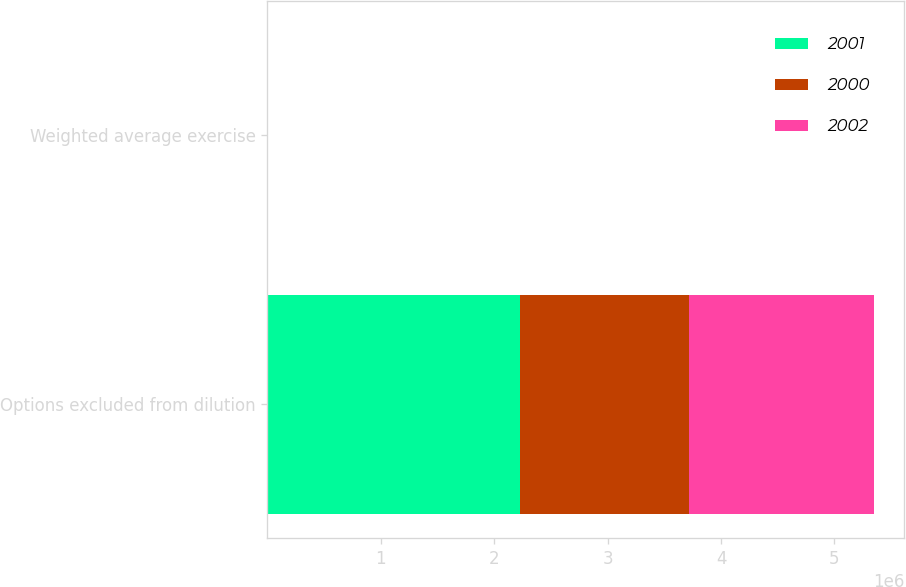Convert chart. <chart><loc_0><loc_0><loc_500><loc_500><stacked_bar_chart><ecel><fcel>Options excluded from dilution<fcel>Weighted average exercise<nl><fcel>2001<fcel>2.22998e+06<fcel>39.77<nl><fcel>2000<fcel>1.4853e+06<fcel>41.29<nl><fcel>2002<fcel>1.63315e+06<fcel>38.39<nl></chart> 